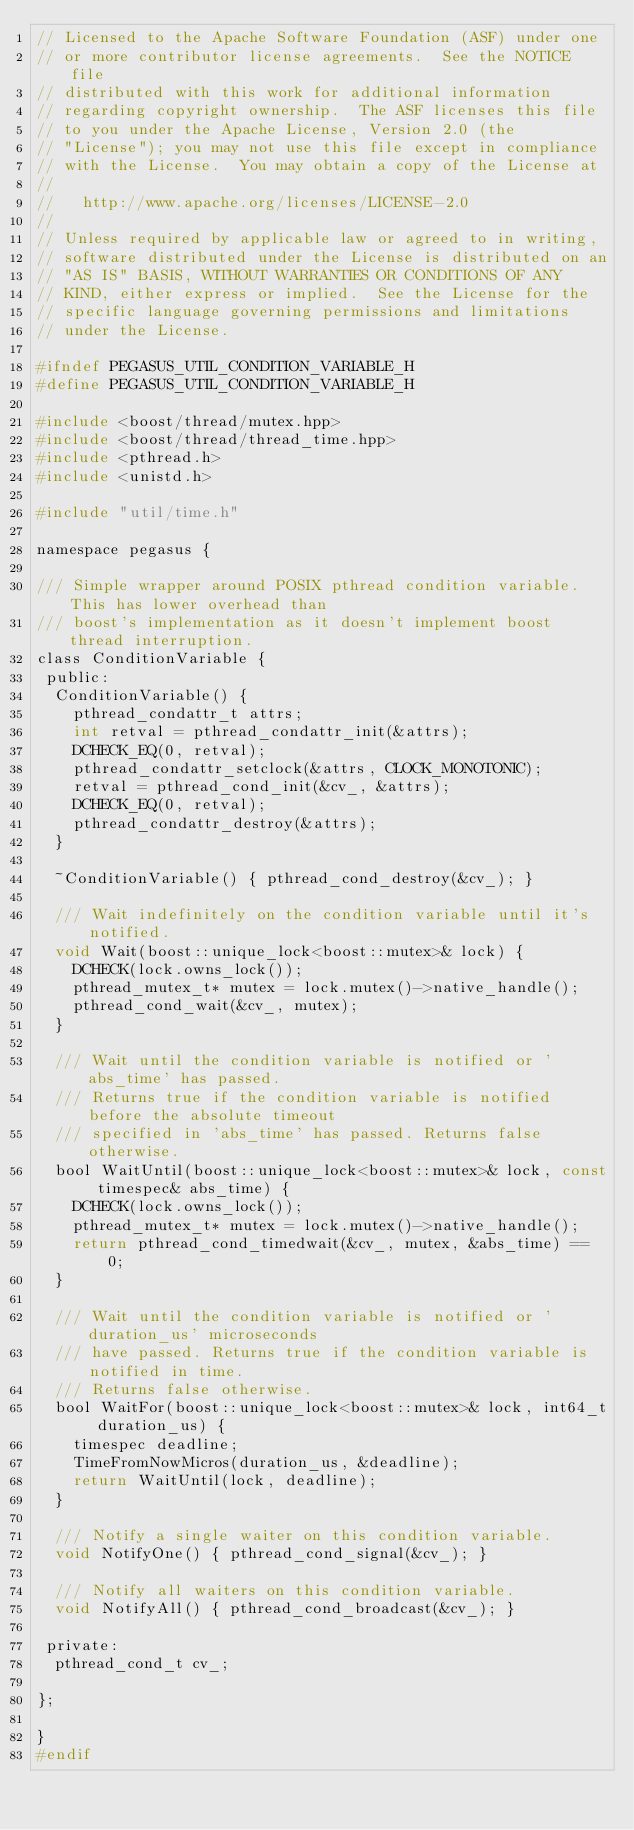Convert code to text. <code><loc_0><loc_0><loc_500><loc_500><_C_>// Licensed to the Apache Software Foundation (ASF) under one
// or more contributor license agreements.  See the NOTICE file
// distributed with this work for additional information
// regarding copyright ownership.  The ASF licenses this file
// to you under the Apache License, Version 2.0 (the
// "License"); you may not use this file except in compliance
// with the License.  You may obtain a copy of the License at
//
//   http://www.apache.org/licenses/LICENSE-2.0
//
// Unless required by applicable law or agreed to in writing,
// software distributed under the License is distributed on an
// "AS IS" BASIS, WITHOUT WARRANTIES OR CONDITIONS OF ANY
// KIND, either express or implied.  See the License for the
// specific language governing permissions and limitations
// under the License.

#ifndef PEGASUS_UTIL_CONDITION_VARIABLE_H
#define PEGASUS_UTIL_CONDITION_VARIABLE_H

#include <boost/thread/mutex.hpp>
#include <boost/thread/thread_time.hpp>
#include <pthread.h>
#include <unistd.h>

#include "util/time.h"

namespace pegasus {

/// Simple wrapper around POSIX pthread condition variable. This has lower overhead than
/// boost's implementation as it doesn't implement boost thread interruption.
class ConditionVariable {
 public:
  ConditionVariable() {
    pthread_condattr_t attrs;
    int retval = pthread_condattr_init(&attrs);
    DCHECK_EQ(0, retval);
    pthread_condattr_setclock(&attrs, CLOCK_MONOTONIC);
    retval = pthread_cond_init(&cv_, &attrs);
    DCHECK_EQ(0, retval);
    pthread_condattr_destroy(&attrs);
  }

  ~ConditionVariable() { pthread_cond_destroy(&cv_); }

  /// Wait indefinitely on the condition variable until it's notified.
  void Wait(boost::unique_lock<boost::mutex>& lock) {
    DCHECK(lock.owns_lock());
    pthread_mutex_t* mutex = lock.mutex()->native_handle();
    pthread_cond_wait(&cv_, mutex);
  }

  /// Wait until the condition variable is notified or 'abs_time' has passed.
  /// Returns true if the condition variable is notified before the absolute timeout
  /// specified in 'abs_time' has passed. Returns false otherwise.
  bool WaitUntil(boost::unique_lock<boost::mutex>& lock, const timespec& abs_time) {
    DCHECK(lock.owns_lock());
    pthread_mutex_t* mutex = lock.mutex()->native_handle();
    return pthread_cond_timedwait(&cv_, mutex, &abs_time) == 0;
  }

  /// Wait until the condition variable is notified or 'duration_us' microseconds
  /// have passed. Returns true if the condition variable is notified in time.
  /// Returns false otherwise.
  bool WaitFor(boost::unique_lock<boost::mutex>& lock, int64_t duration_us) {
    timespec deadline;
    TimeFromNowMicros(duration_us, &deadline);
    return WaitUntil(lock, deadline);
  }

  /// Notify a single waiter on this condition variable.
  void NotifyOne() { pthread_cond_signal(&cv_); }

  /// Notify all waiters on this condition variable.
  void NotifyAll() { pthread_cond_broadcast(&cv_); }

 private:
  pthread_cond_t cv_;

};

}
#endif
</code> 